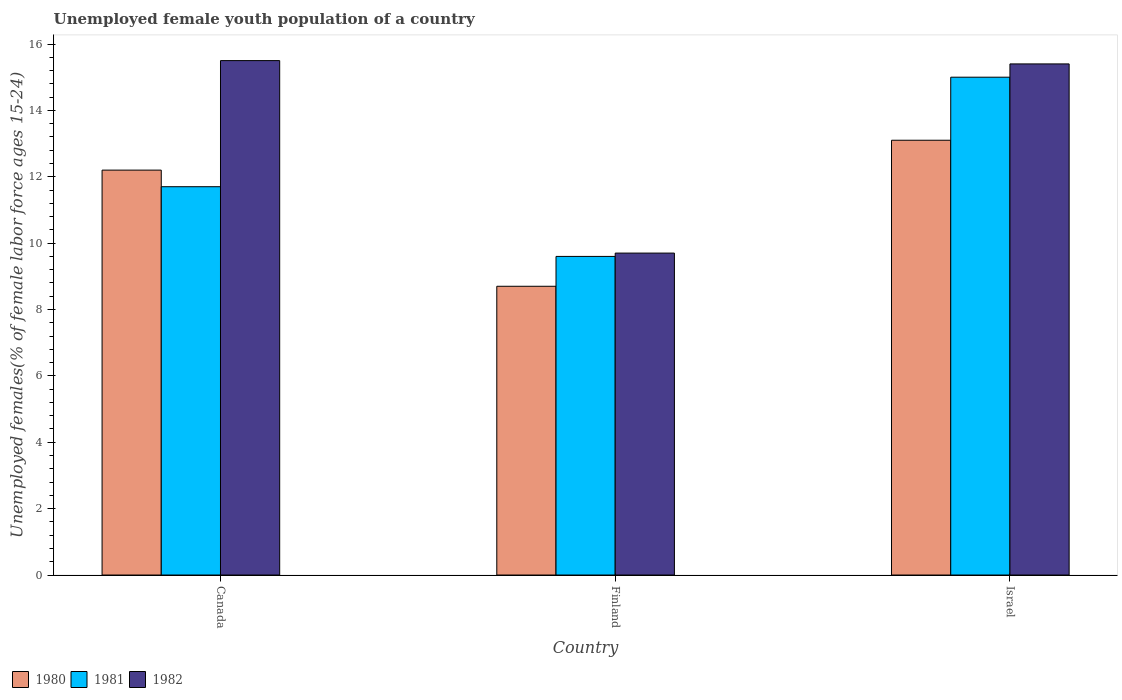How many groups of bars are there?
Offer a very short reply. 3. Are the number of bars per tick equal to the number of legend labels?
Offer a terse response. Yes. Are the number of bars on each tick of the X-axis equal?
Offer a very short reply. Yes. How many bars are there on the 3rd tick from the left?
Offer a very short reply. 3. What is the label of the 3rd group of bars from the left?
Offer a terse response. Israel. What is the percentage of unemployed female youth population in 1982 in Finland?
Offer a very short reply. 9.7. Across all countries, what is the minimum percentage of unemployed female youth population in 1982?
Offer a very short reply. 9.7. What is the total percentage of unemployed female youth population in 1981 in the graph?
Ensure brevity in your answer.  36.3. What is the difference between the percentage of unemployed female youth population in 1982 in Finland and that in Israel?
Provide a succinct answer. -5.7. What is the difference between the percentage of unemployed female youth population in 1981 in Israel and the percentage of unemployed female youth population in 1982 in Finland?
Keep it short and to the point. 5.3. What is the average percentage of unemployed female youth population in 1982 per country?
Keep it short and to the point. 13.53. What is the difference between the percentage of unemployed female youth population of/in 1982 and percentage of unemployed female youth population of/in 1980 in Canada?
Provide a succinct answer. 3.3. In how many countries, is the percentage of unemployed female youth population in 1981 greater than 9.6 %?
Provide a succinct answer. 3. What is the ratio of the percentage of unemployed female youth population in 1981 in Finland to that in Israel?
Provide a succinct answer. 0.64. Is the percentage of unemployed female youth population in 1982 in Canada less than that in Finland?
Provide a short and direct response. No. What is the difference between the highest and the second highest percentage of unemployed female youth population in 1980?
Offer a terse response. -3.5. What is the difference between the highest and the lowest percentage of unemployed female youth population in 1982?
Offer a very short reply. 5.8. Is the sum of the percentage of unemployed female youth population in 1980 in Finland and Israel greater than the maximum percentage of unemployed female youth population in 1981 across all countries?
Offer a very short reply. Yes. What does the 3rd bar from the left in Israel represents?
Your response must be concise. 1982. What does the 3rd bar from the right in Finland represents?
Ensure brevity in your answer.  1980. How many countries are there in the graph?
Offer a very short reply. 3. What is the difference between two consecutive major ticks on the Y-axis?
Offer a very short reply. 2. Are the values on the major ticks of Y-axis written in scientific E-notation?
Your answer should be very brief. No. Where does the legend appear in the graph?
Provide a succinct answer. Bottom left. What is the title of the graph?
Provide a short and direct response. Unemployed female youth population of a country. What is the label or title of the Y-axis?
Your answer should be compact. Unemployed females(% of female labor force ages 15-24). What is the Unemployed females(% of female labor force ages 15-24) of 1980 in Canada?
Ensure brevity in your answer.  12.2. What is the Unemployed females(% of female labor force ages 15-24) in 1981 in Canada?
Your answer should be compact. 11.7. What is the Unemployed females(% of female labor force ages 15-24) of 1982 in Canada?
Your answer should be compact. 15.5. What is the Unemployed females(% of female labor force ages 15-24) of 1980 in Finland?
Offer a terse response. 8.7. What is the Unemployed females(% of female labor force ages 15-24) in 1981 in Finland?
Offer a terse response. 9.6. What is the Unemployed females(% of female labor force ages 15-24) of 1982 in Finland?
Provide a short and direct response. 9.7. What is the Unemployed females(% of female labor force ages 15-24) in 1980 in Israel?
Your response must be concise. 13.1. What is the Unemployed females(% of female labor force ages 15-24) in 1982 in Israel?
Your answer should be compact. 15.4. Across all countries, what is the maximum Unemployed females(% of female labor force ages 15-24) in 1980?
Your response must be concise. 13.1. Across all countries, what is the maximum Unemployed females(% of female labor force ages 15-24) in 1982?
Your response must be concise. 15.5. Across all countries, what is the minimum Unemployed females(% of female labor force ages 15-24) of 1980?
Keep it short and to the point. 8.7. Across all countries, what is the minimum Unemployed females(% of female labor force ages 15-24) of 1981?
Provide a succinct answer. 9.6. Across all countries, what is the minimum Unemployed females(% of female labor force ages 15-24) in 1982?
Provide a short and direct response. 9.7. What is the total Unemployed females(% of female labor force ages 15-24) of 1980 in the graph?
Your answer should be very brief. 34. What is the total Unemployed females(% of female labor force ages 15-24) in 1981 in the graph?
Your response must be concise. 36.3. What is the total Unemployed females(% of female labor force ages 15-24) in 1982 in the graph?
Keep it short and to the point. 40.6. What is the difference between the Unemployed females(% of female labor force ages 15-24) in 1981 in Canada and that in Finland?
Make the answer very short. 2.1. What is the difference between the Unemployed females(% of female labor force ages 15-24) in 1982 in Canada and that in Finland?
Your answer should be very brief. 5.8. What is the difference between the Unemployed females(% of female labor force ages 15-24) of 1980 in Canada and that in Israel?
Give a very brief answer. -0.9. What is the difference between the Unemployed females(% of female labor force ages 15-24) of 1980 in Finland and that in Israel?
Your response must be concise. -4.4. What is the difference between the Unemployed females(% of female labor force ages 15-24) of 1980 in Canada and the Unemployed females(% of female labor force ages 15-24) of 1982 in Finland?
Keep it short and to the point. 2.5. What is the difference between the Unemployed females(% of female labor force ages 15-24) of 1981 in Canada and the Unemployed females(% of female labor force ages 15-24) of 1982 in Finland?
Offer a very short reply. 2. What is the difference between the Unemployed females(% of female labor force ages 15-24) of 1981 in Canada and the Unemployed females(% of female labor force ages 15-24) of 1982 in Israel?
Your answer should be very brief. -3.7. What is the average Unemployed females(% of female labor force ages 15-24) of 1980 per country?
Your answer should be compact. 11.33. What is the average Unemployed females(% of female labor force ages 15-24) of 1981 per country?
Give a very brief answer. 12.1. What is the average Unemployed females(% of female labor force ages 15-24) in 1982 per country?
Provide a short and direct response. 13.53. What is the difference between the Unemployed females(% of female labor force ages 15-24) of 1980 and Unemployed females(% of female labor force ages 15-24) of 1982 in Canada?
Provide a succinct answer. -3.3. What is the difference between the Unemployed females(% of female labor force ages 15-24) of 1981 and Unemployed females(% of female labor force ages 15-24) of 1982 in Canada?
Provide a short and direct response. -3.8. What is the difference between the Unemployed females(% of female labor force ages 15-24) of 1980 and Unemployed females(% of female labor force ages 15-24) of 1981 in Finland?
Give a very brief answer. -0.9. What is the difference between the Unemployed females(% of female labor force ages 15-24) of 1980 and Unemployed females(% of female labor force ages 15-24) of 1982 in Finland?
Make the answer very short. -1. What is the difference between the Unemployed females(% of female labor force ages 15-24) in 1981 and Unemployed females(% of female labor force ages 15-24) in 1982 in Finland?
Keep it short and to the point. -0.1. What is the difference between the Unemployed females(% of female labor force ages 15-24) of 1981 and Unemployed females(% of female labor force ages 15-24) of 1982 in Israel?
Your answer should be compact. -0.4. What is the ratio of the Unemployed females(% of female labor force ages 15-24) of 1980 in Canada to that in Finland?
Your response must be concise. 1.4. What is the ratio of the Unemployed females(% of female labor force ages 15-24) of 1981 in Canada to that in Finland?
Your answer should be compact. 1.22. What is the ratio of the Unemployed females(% of female labor force ages 15-24) in 1982 in Canada to that in Finland?
Ensure brevity in your answer.  1.6. What is the ratio of the Unemployed females(% of female labor force ages 15-24) in 1980 in Canada to that in Israel?
Your answer should be compact. 0.93. What is the ratio of the Unemployed females(% of female labor force ages 15-24) of 1981 in Canada to that in Israel?
Offer a very short reply. 0.78. What is the ratio of the Unemployed females(% of female labor force ages 15-24) of 1982 in Canada to that in Israel?
Ensure brevity in your answer.  1.01. What is the ratio of the Unemployed females(% of female labor force ages 15-24) of 1980 in Finland to that in Israel?
Your answer should be very brief. 0.66. What is the ratio of the Unemployed females(% of female labor force ages 15-24) of 1981 in Finland to that in Israel?
Provide a succinct answer. 0.64. What is the ratio of the Unemployed females(% of female labor force ages 15-24) of 1982 in Finland to that in Israel?
Ensure brevity in your answer.  0.63. What is the difference between the highest and the second highest Unemployed females(% of female labor force ages 15-24) in 1980?
Provide a short and direct response. 0.9. What is the difference between the highest and the lowest Unemployed females(% of female labor force ages 15-24) in 1981?
Offer a very short reply. 5.4. 